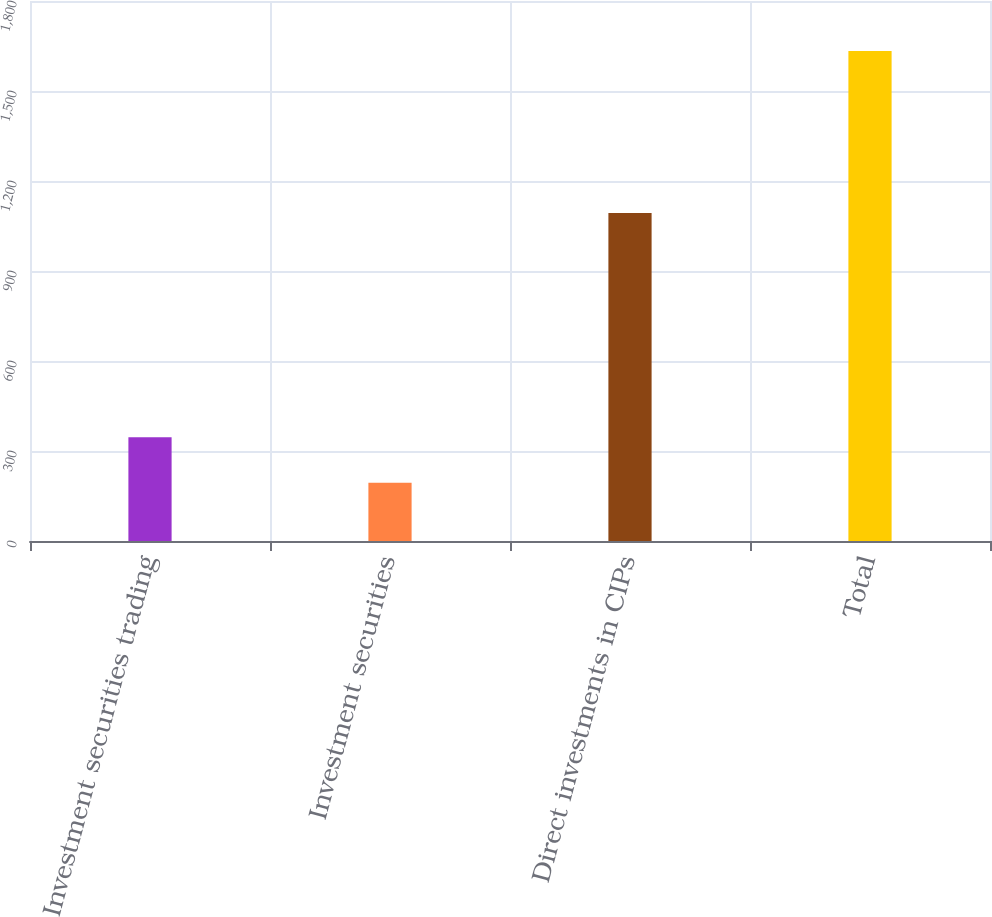<chart> <loc_0><loc_0><loc_500><loc_500><bar_chart><fcel>Investment securities trading<fcel>Investment securities<fcel>Direct investments in CIPs<fcel>Total<nl><fcel>345.7<fcel>194.1<fcel>1093.5<fcel>1633.3<nl></chart> 